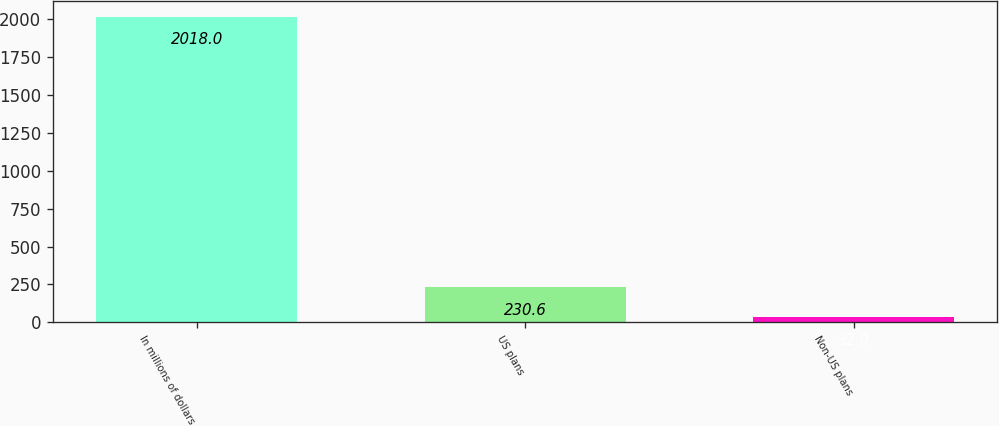Convert chart to OTSL. <chart><loc_0><loc_0><loc_500><loc_500><bar_chart><fcel>In millions of dollars<fcel>US plans<fcel>Non-US plans<nl><fcel>2018<fcel>230.6<fcel>32<nl></chart> 